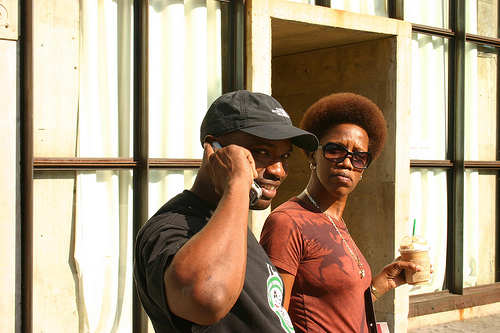How many people are there? There are two people in the image, a man and a woman. The man is wearing a black cap and seems to be in the middle of a phone conversation, while the woman is standing slightly behind him holding a beverage, and she has a focused expression on her face. 